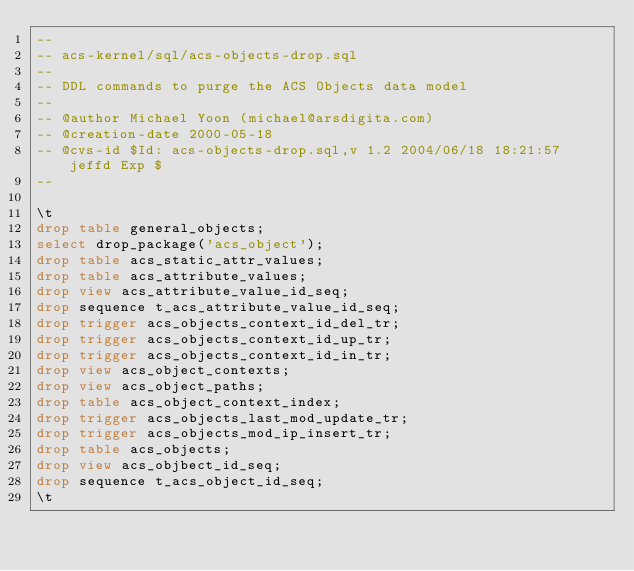Convert code to text. <code><loc_0><loc_0><loc_500><loc_500><_SQL_>--
-- acs-kernel/sql/acs-objects-drop.sql
--
-- DDL commands to purge the ACS Objects data model
--
-- @author Michael Yoon (michael@arsdigita.com)
-- @creation-date 2000-05-18
-- @cvs-id $Id: acs-objects-drop.sql,v 1.2 2004/06/18 18:21:57 jeffd Exp $
--

\t
drop table general_objects;
select drop_package('acs_object');
drop table acs_static_attr_values;
drop table acs_attribute_values;
drop view acs_attribute_value_id_seq;
drop sequence t_acs_attribute_value_id_seq;
drop trigger acs_objects_context_id_del_tr;
drop trigger acs_objects_context_id_up_tr;
drop trigger acs_objects_context_id_in_tr;
drop view acs_object_contexts;
drop view acs_object_paths;
drop table acs_object_context_index;
drop trigger acs_objects_last_mod_update_tr;
drop trigger acs_objects_mod_ip_insert_tr;
drop table acs_objects;
drop view acs_objbect_id_seq;
drop sequence t_acs_object_id_seq;
\t
</code> 